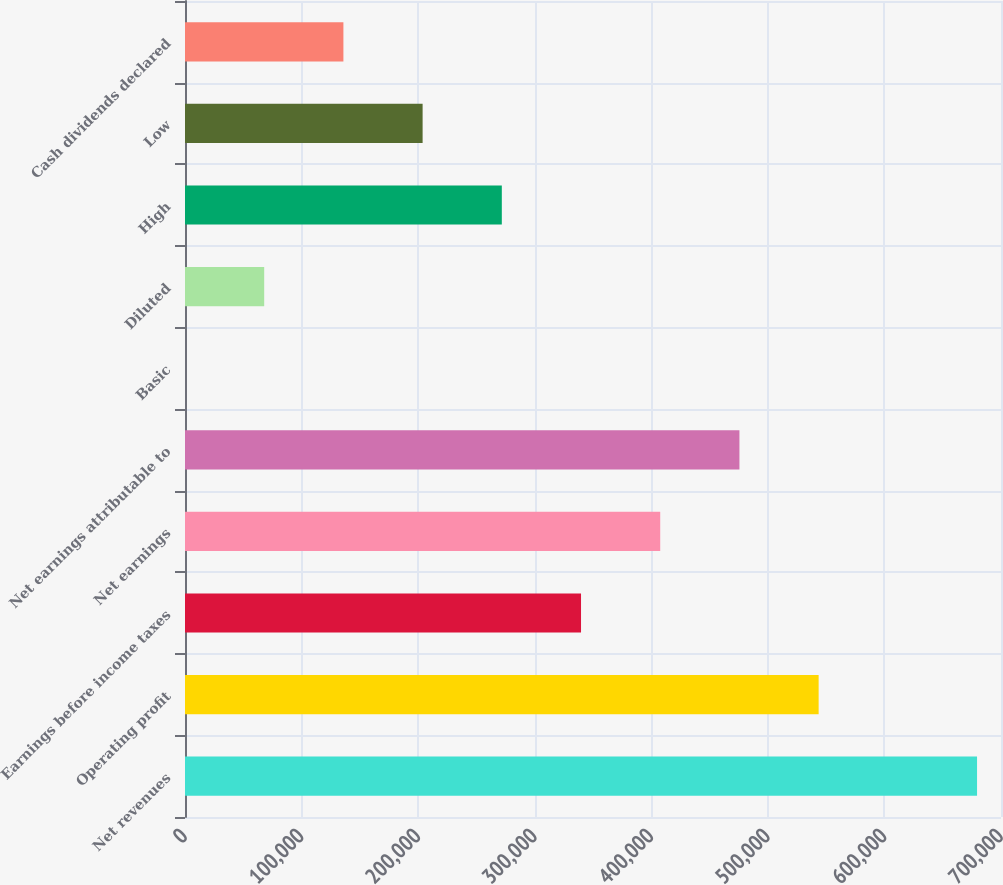Convert chart. <chart><loc_0><loc_0><loc_500><loc_500><bar_chart><fcel>Net revenues<fcel>Operating profit<fcel>Earnings before income taxes<fcel>Net earnings<fcel>Net earnings attributable to<fcel>Basic<fcel>Diluted<fcel>High<fcel>Low<fcel>Cash dividends declared<nl><fcel>679453<fcel>543562<fcel>339727<fcel>407672<fcel>475617<fcel>0.24<fcel>67945.5<fcel>271781<fcel>203836<fcel>135891<nl></chart> 